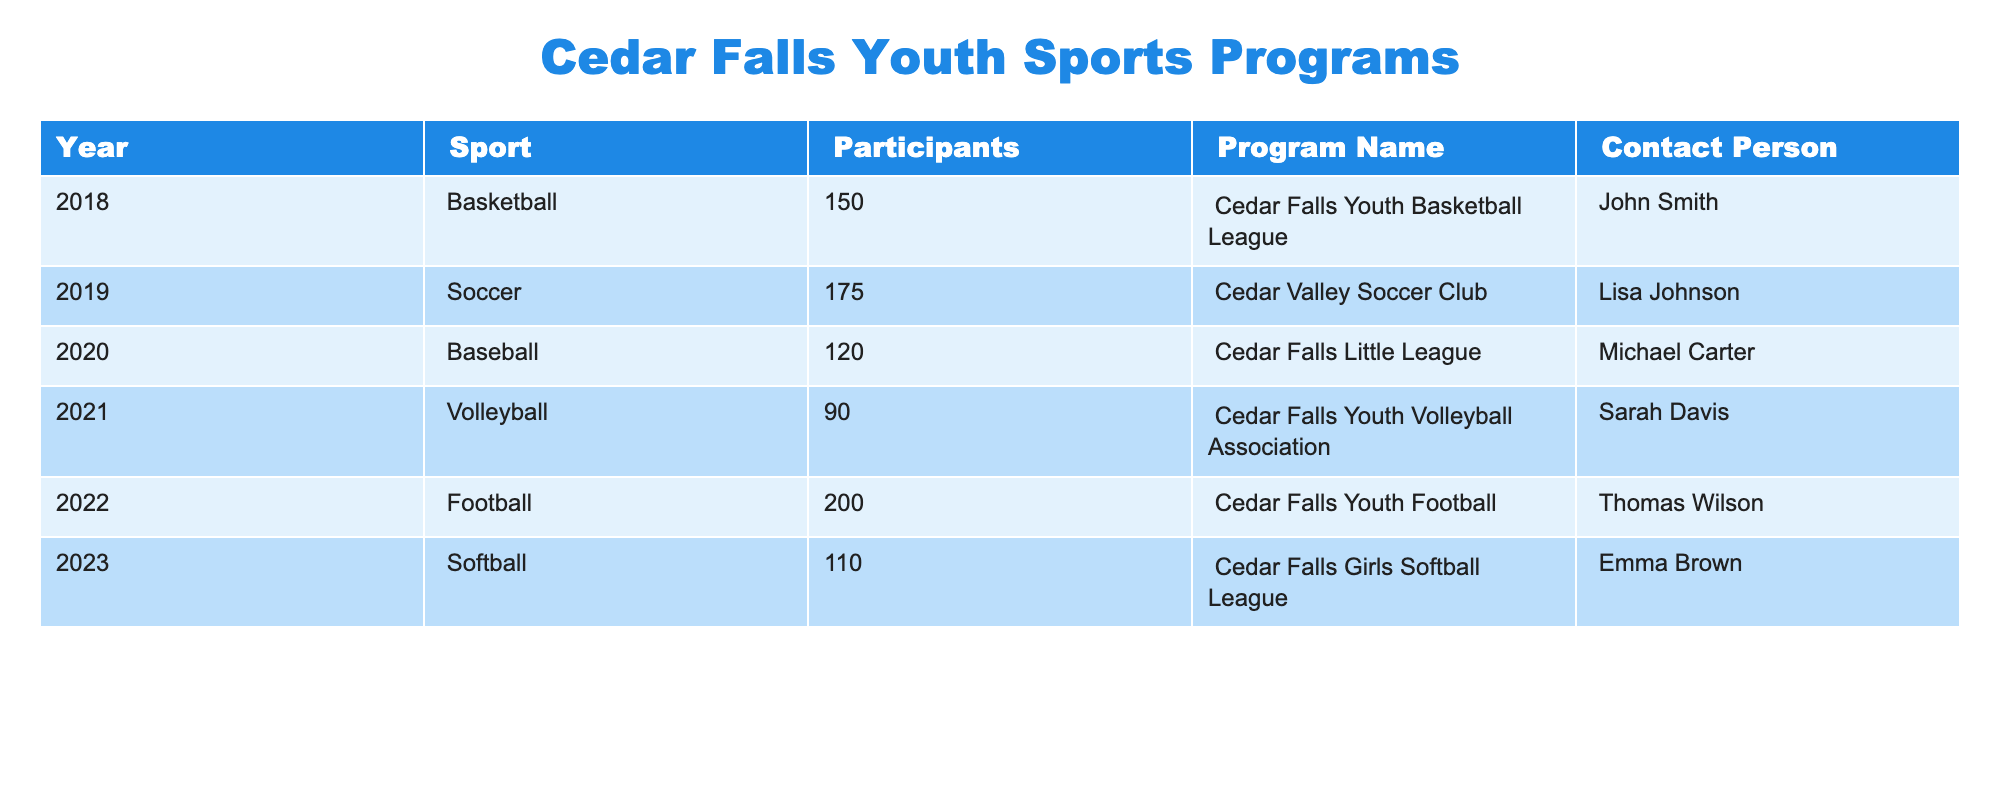What was the highest participation rate for a sport in Cedar Falls youth sports programs from 2018 to 2023? The table shows the number of participants for each sport per year; Football in 2022 had the highest number of participants at 200.
Answer: 200 Which sport had the least participants in 2021? Referring to the table, Volleyball had the least participants in 2021 with a count of 90.
Answer: 90 How many total participants were recorded for youth sports in Cedar Falls from 2018 to 2023? We need to sum up all the participants: 150 (Basketball) + 175 (Soccer) + 120 (Baseball) + 90 (Volleyball) + 200 (Football) + 110 (Softball) = 945.
Answer: 945 Did the number of participants in Baseball increase or decrease from 2020 to 2023? The number of participants in Baseball was 120 in 2020 and 110 in 2023, which indicates a decrease of 10 participants.
Answer: Decrease What percentage of total participants were involved in Soccer in 2019? To find the percentage: Soccer had 175 participants out of a total of 945. The calculation is (175 / 945) * 100 ≈ 18.5%.
Answer: Approximately 18.5% Was there any year when the participation in youth sports was below 100? According to the table, Volleyball in 2021 had 90 participants, which is below 100. Therefore, the answer is yes.
Answer: Yes Which sports program had the largest number of participants over the years 2018 to 2023 combined? We compare the participants across all years: Basketball (150) + Soccer (175) + Baseball (120) + Volleyball (90) + Football (200) + Softball (110) gives us totals for each sport. Soccer has 175 maximum for a single year but not the overall maximum. Football at 200 in 2022 is the highest for a single year and thus combined as it sums highest. Therefore the Cedar Falls Youth Football program is the answer.
Answer: Cedar Falls Youth Football What has been the average participation rate in Cedar Falls youth sports across all sports from 2018 to 2023? To find the average, we calculate the total participants (945) and divide by the number of years (6). The average calculation is 945 / 6 = 157.5.
Answer: 157.5 Which sport had more participants: Softball or Volleyball? From the table, Softball had 110 participants in 2023 and Volleyball had 90 in 2021. Comparing these two values, Softball had more participants.
Answer: Softball had more participants 